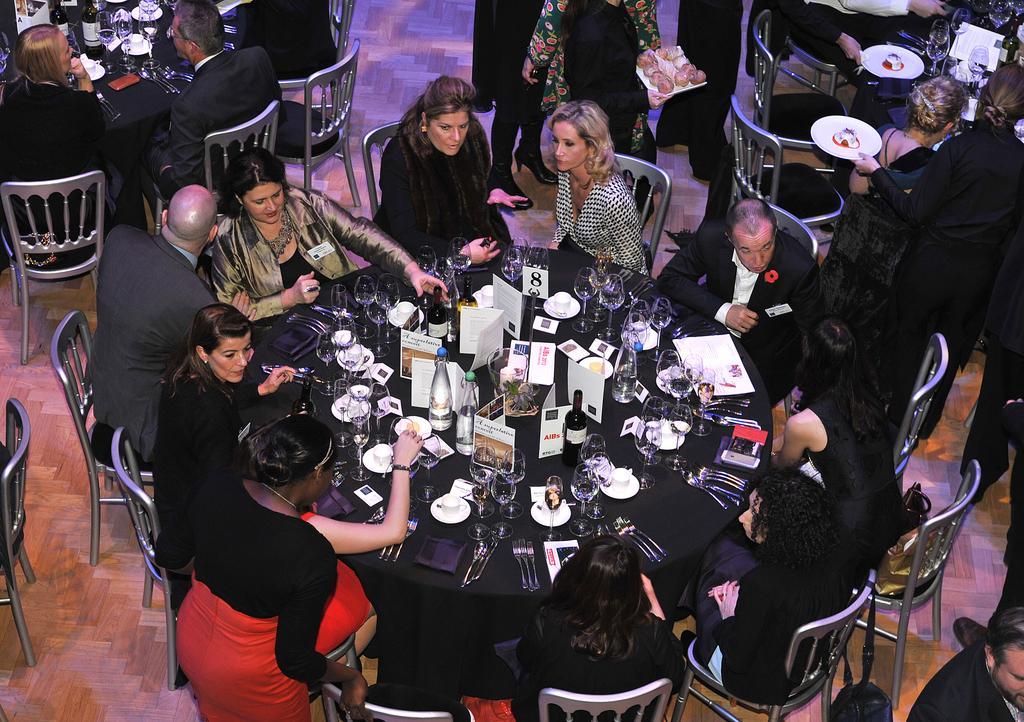Describe this image in one or two sentences. In this image I can see group of people sitting and I can see few bottles, glasses, few spoons and few objects on the table. 